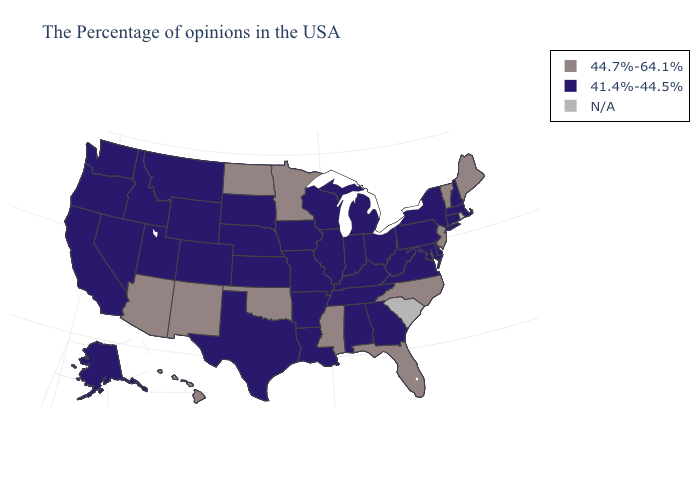What is the value of Rhode Island?
Give a very brief answer. N/A. Does the map have missing data?
Short answer required. Yes. What is the highest value in the South ?
Be succinct. 44.7%-64.1%. Among the states that border New Mexico , which have the lowest value?
Answer briefly. Texas, Colorado, Utah. Does New Jersey have the lowest value in the USA?
Give a very brief answer. No. What is the value of Illinois?
Give a very brief answer. 41.4%-44.5%. What is the value of Washington?
Quick response, please. 41.4%-44.5%. Among the states that border Arkansas , which have the highest value?
Give a very brief answer. Mississippi, Oklahoma. What is the highest value in states that border Pennsylvania?
Keep it brief. 44.7%-64.1%. What is the value of Nevada?
Answer briefly. 41.4%-44.5%. Does the map have missing data?
Be succinct. Yes. Name the states that have a value in the range 41.4%-44.5%?
Answer briefly. Massachusetts, New Hampshire, Connecticut, New York, Delaware, Maryland, Pennsylvania, Virginia, West Virginia, Ohio, Georgia, Michigan, Kentucky, Indiana, Alabama, Tennessee, Wisconsin, Illinois, Louisiana, Missouri, Arkansas, Iowa, Kansas, Nebraska, Texas, South Dakota, Wyoming, Colorado, Utah, Montana, Idaho, Nevada, California, Washington, Oregon, Alaska. Among the states that border Washington , which have the highest value?
Quick response, please. Idaho, Oregon. 